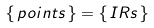Convert formula to latex. <formula><loc_0><loc_0><loc_500><loc_500>\{ \, p o i n t s \, \} = \{ \, I R s \, \}</formula> 